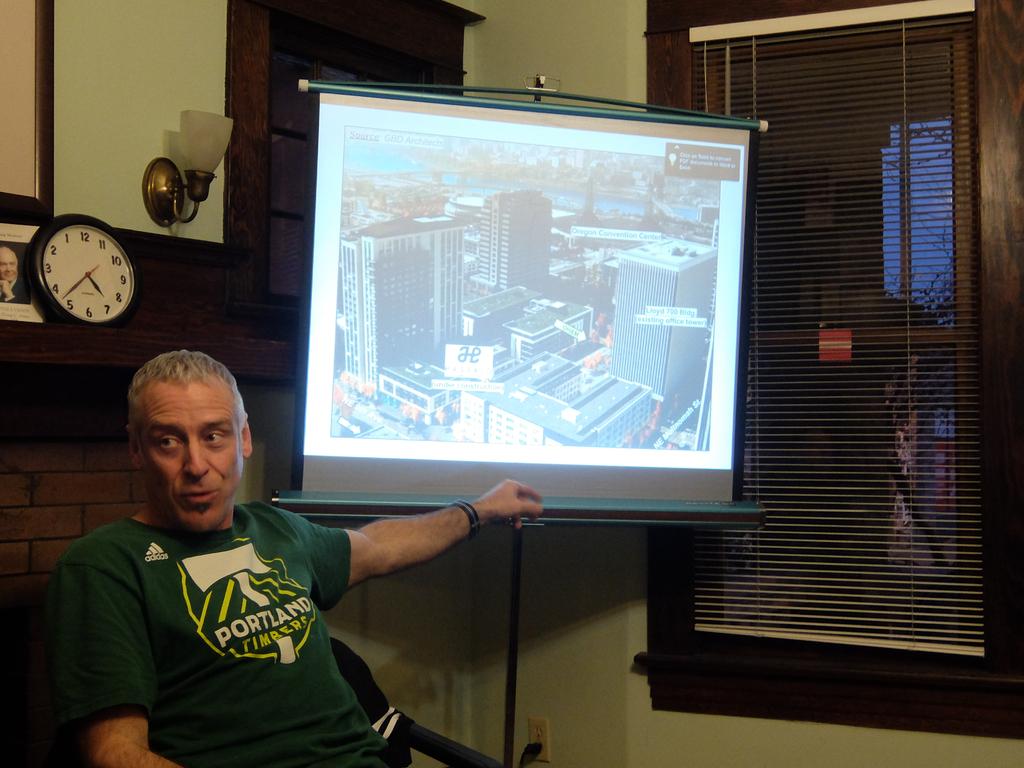What city is imprinted on the green shirt?
Keep it short and to the point. Portland. 